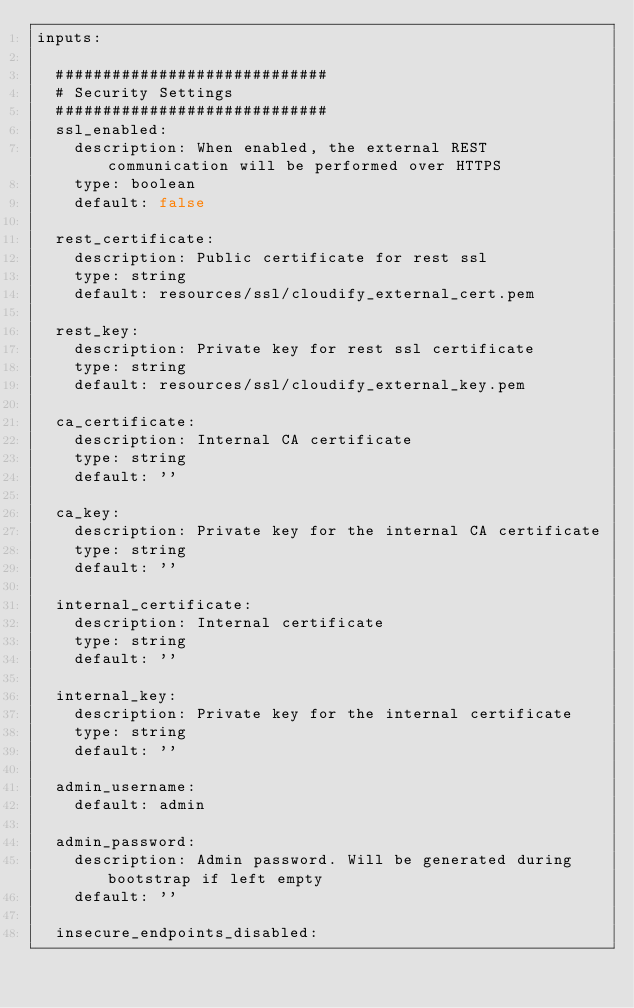<code> <loc_0><loc_0><loc_500><loc_500><_YAML_>inputs:

  #############################
  # Security Settings
  #############################
  ssl_enabled:
    description: When enabled, the external REST communication will be performed over HTTPS
    type: boolean
    default: false

  rest_certificate:
    description: Public certificate for rest ssl
    type: string
    default: resources/ssl/cloudify_external_cert.pem

  rest_key:
    description: Private key for rest ssl certificate
    type: string
    default: resources/ssl/cloudify_external_key.pem

  ca_certificate:
    description: Internal CA certificate
    type: string
    default: ''

  ca_key:
    description: Private key for the internal CA certificate
    type: string
    default: ''

  internal_certificate:
    description: Internal certificate
    type: string
    default: ''

  internal_key:
    description: Private key for the internal certificate
    type: string
    default: ''

  admin_username:
    default: admin

  admin_password:
    description: Admin password. Will be generated during bootstrap if left empty
    default: ''

  insecure_endpoints_disabled:</code> 